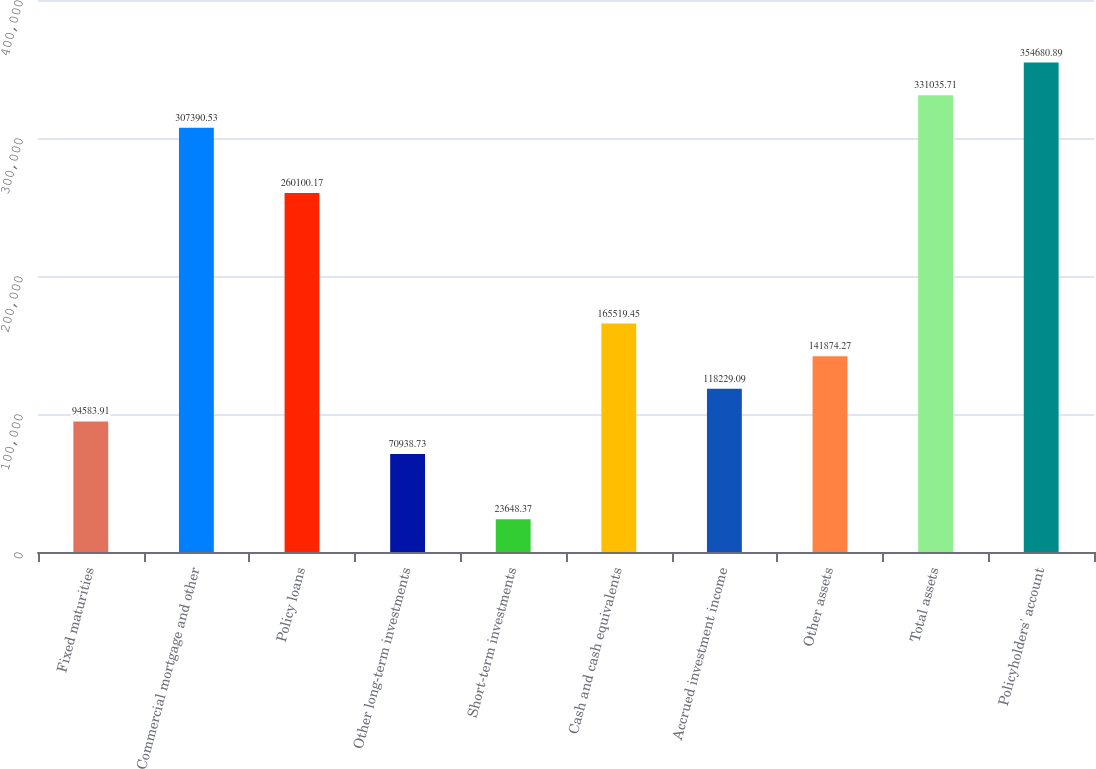Convert chart to OTSL. <chart><loc_0><loc_0><loc_500><loc_500><bar_chart><fcel>Fixed maturities<fcel>Commercial mortgage and other<fcel>Policy loans<fcel>Other long-term investments<fcel>Short-term investments<fcel>Cash and cash equivalents<fcel>Accrued investment income<fcel>Other assets<fcel>Total assets<fcel>Policyholders' account<nl><fcel>94583.9<fcel>307391<fcel>260100<fcel>70938.7<fcel>23648.4<fcel>165519<fcel>118229<fcel>141874<fcel>331036<fcel>354681<nl></chart> 